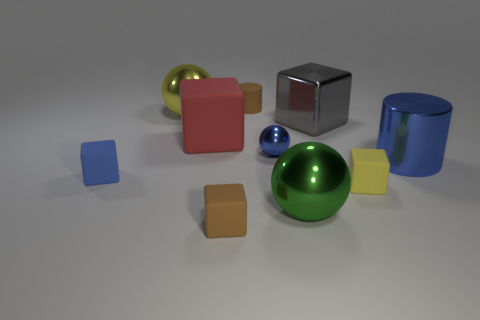Subtract all tiny yellow matte blocks. How many blocks are left? 4 Subtract all blue spheres. How many spheres are left? 2 Subtract 1 spheres. How many spheres are left? 2 Subtract all balls. How many objects are left? 7 Subtract 0 purple cubes. How many objects are left? 10 Subtract all yellow cylinders. Subtract all blue cubes. How many cylinders are left? 2 Subtract all red things. Subtract all red blocks. How many objects are left? 8 Add 3 large yellow shiny objects. How many large yellow shiny objects are left? 4 Add 4 large yellow things. How many large yellow things exist? 5 